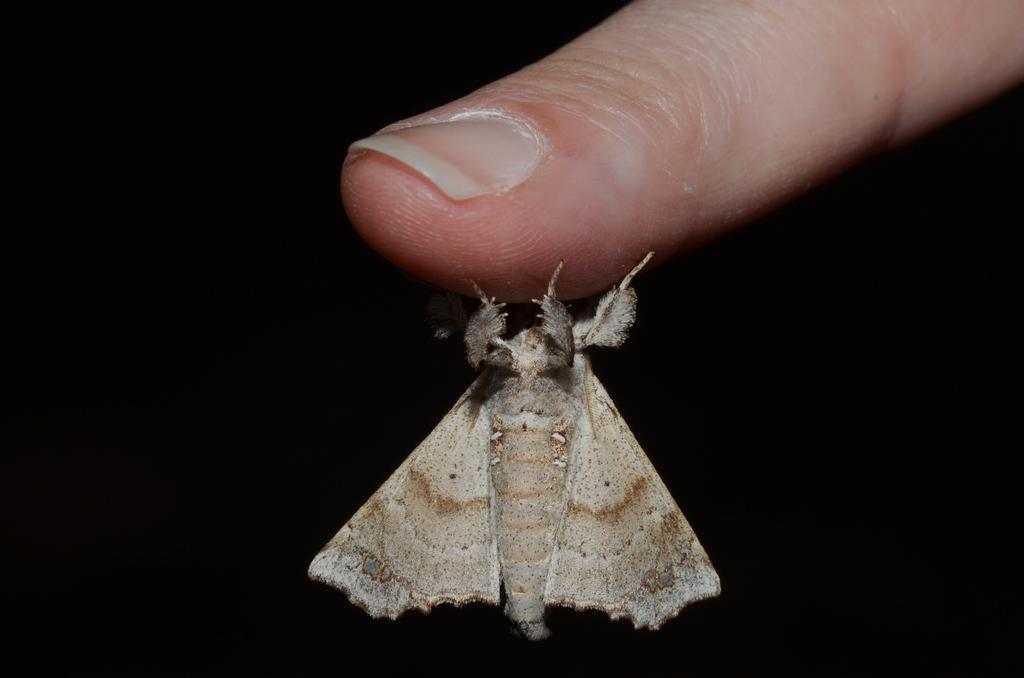What type of creature is in the picture? There is an insect in the picture. What is the insect doing in the image? The insect is holding a finger. Can you describe the color of the insect? The insect has a cream and brown color. What type of quilt is visible on the floor in the image? There is no quilt present in the image; it only features an insect holding a finger. 